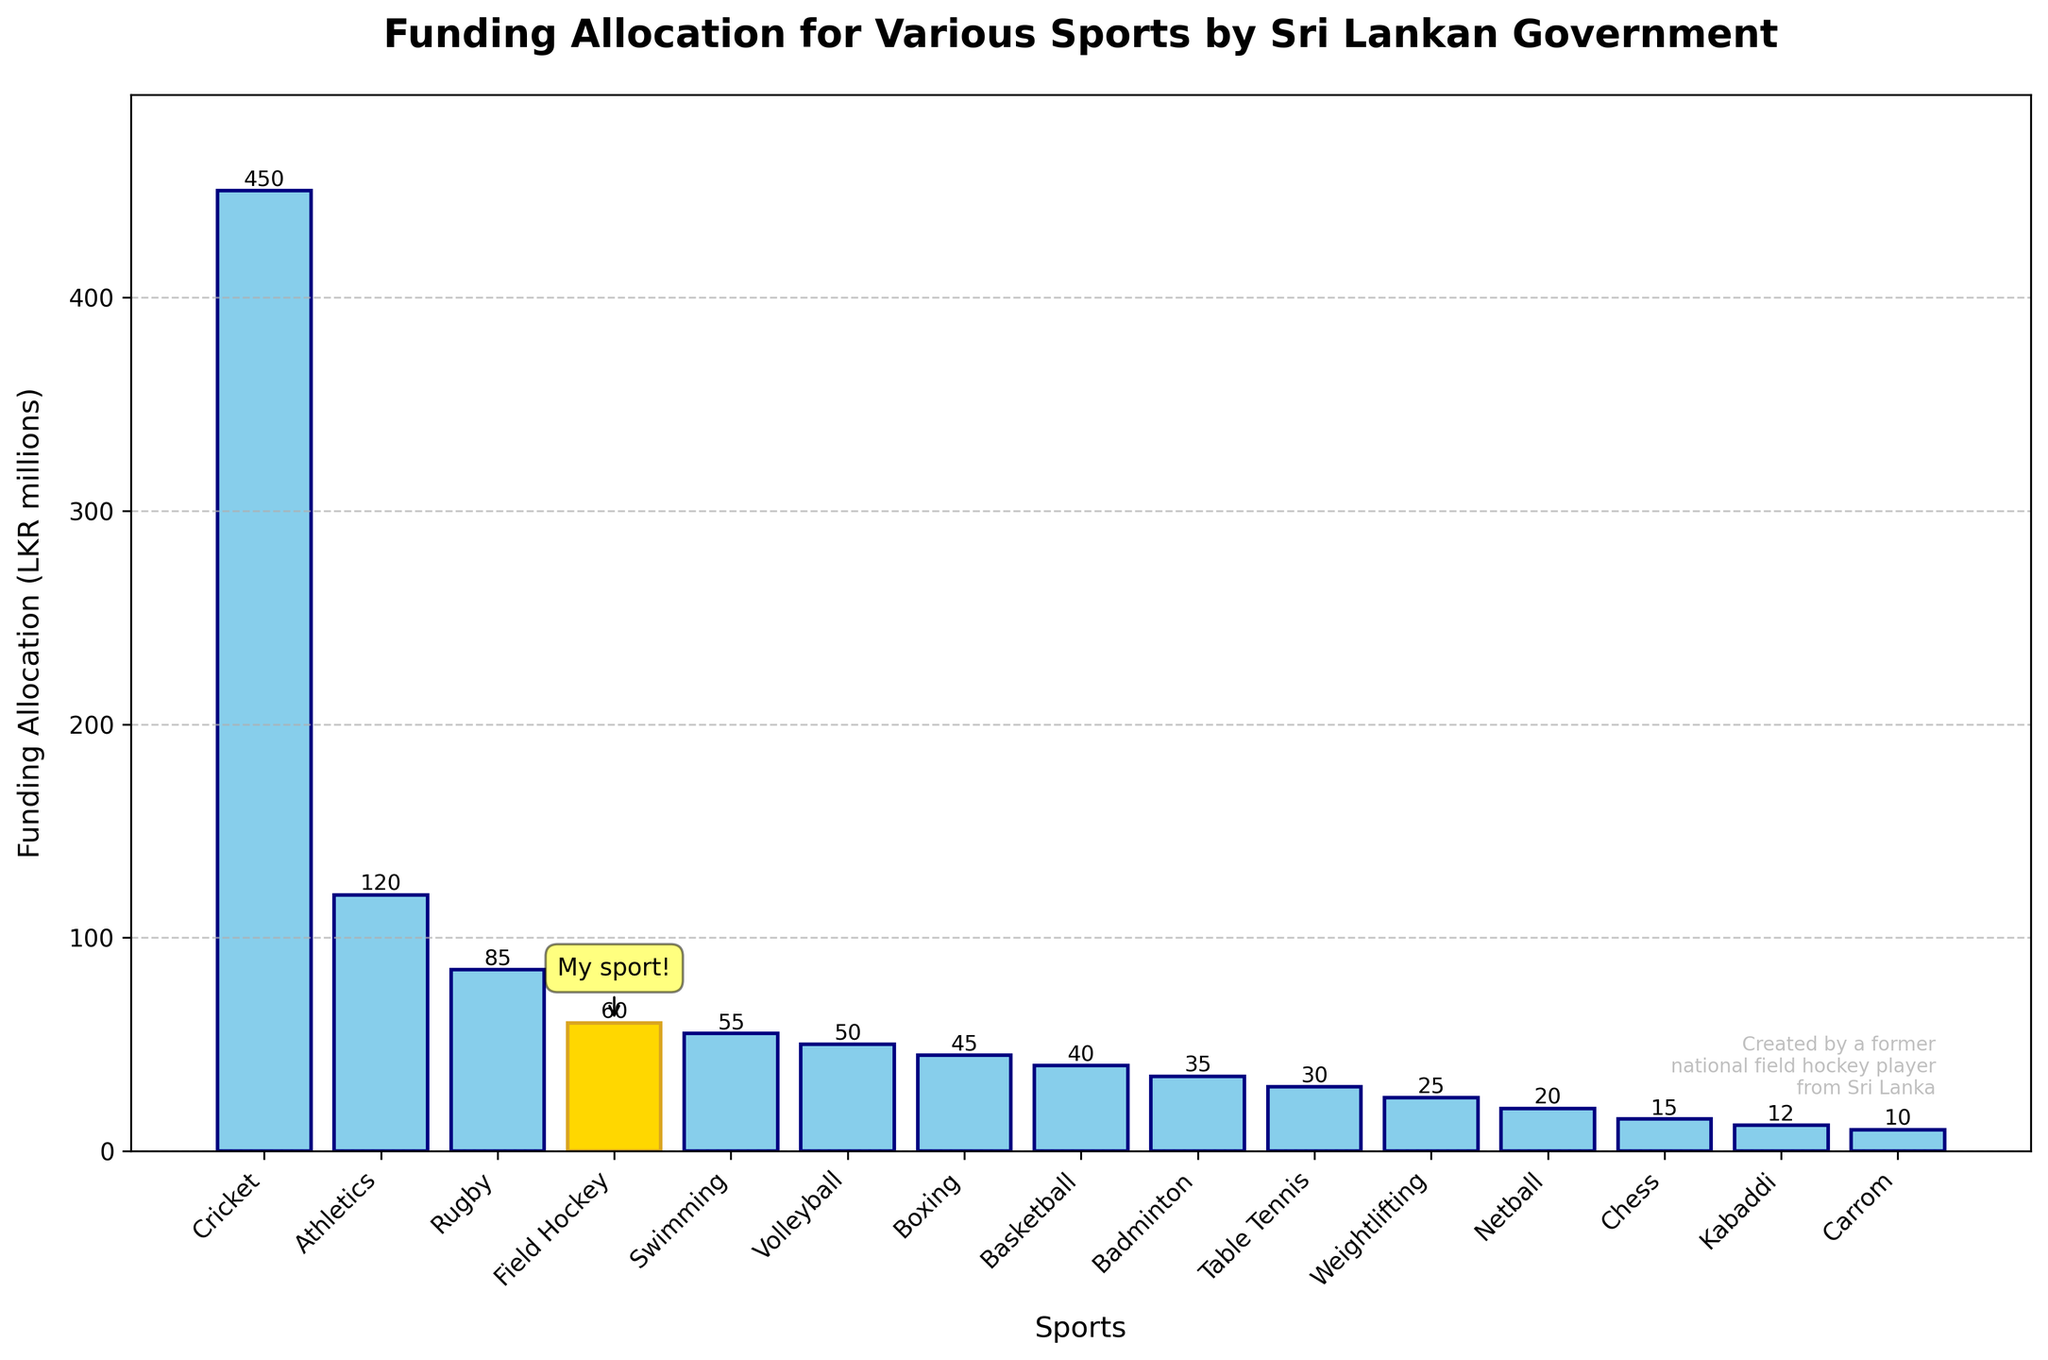What's the total funding allocation for Cricket and Athletics combined? To find the total funding allocation for Cricket and Athletics, sum their respective funding amounts: Cricket (450 LKR millions) + Athletics (120 LKR millions).
Answer: 570 What is the difference in funding allocation between the highest funded sport and Field Hockey? The highest funded sport is Cricket (450 LKR millions) and Field Hockey receives 60 LKR millions. The difference is 450 - 60 = 390 LKR millions.
Answer: 390 Which sport receives more funding: Swimming or Volleyball? By comparing the heights of the bars, Swimming receives 55 LKR millions while Volleyball receives 50 LKR millions. Swimming receives more funding.
Answer: Swimming How much more funding does Rugby receive compared to Badminton? To find out, subtract Badminton's funding from Rugby's funding: Rugby (85 LKR millions) - Badminton (35 LKR millions).
Answer: 50 Is the funding allocated to Boxing more or less than Netball and Chess combined? Sum the funding for Netball and Chess: Netball (20 LKR millions) + Chess (15 LKR millions) = 35 LKR millions. Boxing receives 45 LKR millions, which is more than 35 LKR millions.
Answer: More What is the average funding allocation across all sports? Sum the funding for all sports and divide by the number of sports: (450+120+85+60+55+50+45+40+35+30+25+20+15+12+10)/15 = 82.67 LKR millions (rounded to 2 decimal places).
Answer: 82.67 Are there more sports receiving below or above 50 LKR millions in funding? Count the number of sports receiving below and above 50 LKR millions: Below (9 sports: Hockey, Swimming, Volleyball, Boxing, Basketball, Badminton, Table Tennis, Weightlifting, Netball, Chess, Kabaddi, Carrom), Above (3 sports: Cricket, Athletics, Rugby). More sports receive below 50 LKR millions.
Answer: Below Which sport has the smallest funding allocation and what is its value? By looking at the height of the bars, Carrom has the smallest funding allocation at 10 LKR millions.
Answer: Carrom, 10 What is the total funding allocation for all sports combined? Sum the funding for all sports: (450+120+85+60+55+50+45+40+35+30+25+20+15+12+10) = 1052 LKR millions.
Answer: 1052 How much more funding does Cricket receive compared to the sum of the funding for the three least funded sports? Identify the three least funded sports: Kabaddi (12 LKR millions), Carrom (10 LKR millions), Chess (15 LKR millions). Sum their funding: 12 + 10 + 15 = 37 LKR millions. Compare this to Cricket: 450 - 37 = 413 LKR millions.
Answer: 413 